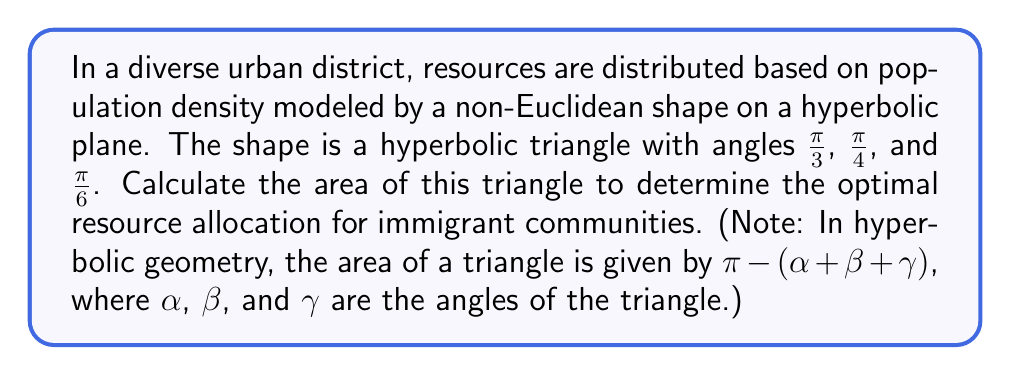Teach me how to tackle this problem. To solve this problem, we'll follow these steps:

1) Recall the formula for the area of a hyperbolic triangle:
   $$A = \pi - (\alpha + \beta + \gamma)$$
   where $A$ is the area, and $\alpha$, $\beta$, and $\gamma$ are the angles of the triangle.

2) We're given the following angles:
   $\alpha = \frac{\pi}{3}$
   $\beta = \frac{\pi}{4}$
   $\gamma = \frac{\pi}{6}$

3) Let's substitute these values into our formula:
   $$A = \pi - (\frac{\pi}{3} + \frac{\pi}{4} + \frac{\pi}{6})$$

4) Now, let's find a common denominator to add the fractions:
   $$A = \pi - (\frac{4\pi}{12} + \frac{3\pi}{12} + \frac{2\pi}{12})$$

5) Add the fractions:
   $$A = \pi - \frac{9\pi}{12}$$

6) Simplify:
   $$A = \pi - \frac{3\pi}{4}$$

7) Subtract:
   $$A = \frac{\pi}{4}$$

Therefore, the area of the hyperbolic triangle representing the resource distribution is $\frac{\pi}{4}$.
Answer: $\frac{\pi}{4}$ 